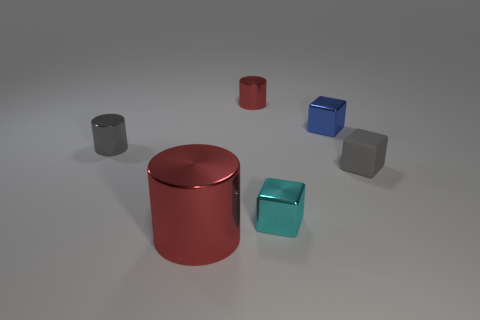Subtract all red balls. How many red cylinders are left? 2 Subtract all red metal cylinders. How many cylinders are left? 1 Subtract 1 cubes. How many cubes are left? 2 Add 4 gray objects. How many objects exist? 10 Add 2 tiny metal things. How many tiny metal things exist? 6 Subtract 0 brown balls. How many objects are left? 6 Subtract all small things. Subtract all small red shiny cylinders. How many objects are left? 0 Add 2 large metal things. How many large metal things are left? 3 